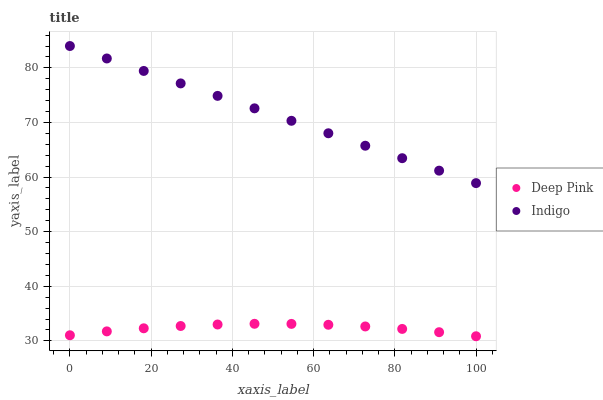Does Deep Pink have the minimum area under the curve?
Answer yes or no. Yes. Does Indigo have the maximum area under the curve?
Answer yes or no. Yes. Does Indigo have the minimum area under the curve?
Answer yes or no. No. Is Indigo the smoothest?
Answer yes or no. Yes. Is Deep Pink the roughest?
Answer yes or no. Yes. Is Indigo the roughest?
Answer yes or no. No. Does Deep Pink have the lowest value?
Answer yes or no. Yes. Does Indigo have the lowest value?
Answer yes or no. No. Does Indigo have the highest value?
Answer yes or no. Yes. Is Deep Pink less than Indigo?
Answer yes or no. Yes. Is Indigo greater than Deep Pink?
Answer yes or no. Yes. Does Deep Pink intersect Indigo?
Answer yes or no. No. 